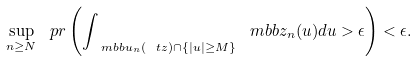<formula> <loc_0><loc_0><loc_500><loc_500>\sup _ { n \geq N } \ p r \left ( \int _ { \ m b b u _ { n } ( \ t z ) \cap \{ | u | \geq M \} } \ m b b z _ { n } ( u ) d u > \epsilon \right ) < \epsilon .</formula> 